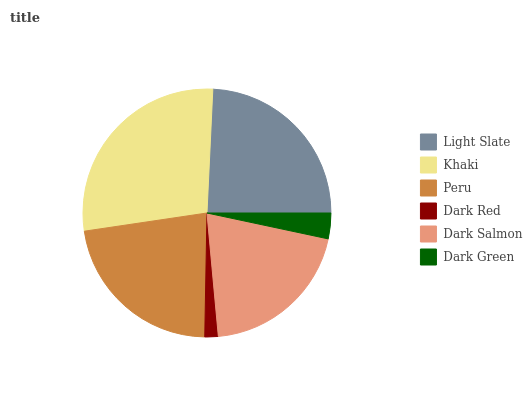Is Dark Red the minimum?
Answer yes or no. Yes. Is Khaki the maximum?
Answer yes or no. Yes. Is Peru the minimum?
Answer yes or no. No. Is Peru the maximum?
Answer yes or no. No. Is Khaki greater than Peru?
Answer yes or no. Yes. Is Peru less than Khaki?
Answer yes or no. Yes. Is Peru greater than Khaki?
Answer yes or no. No. Is Khaki less than Peru?
Answer yes or no. No. Is Peru the high median?
Answer yes or no. Yes. Is Dark Salmon the low median?
Answer yes or no. Yes. Is Dark Green the high median?
Answer yes or no. No. Is Peru the low median?
Answer yes or no. No. 